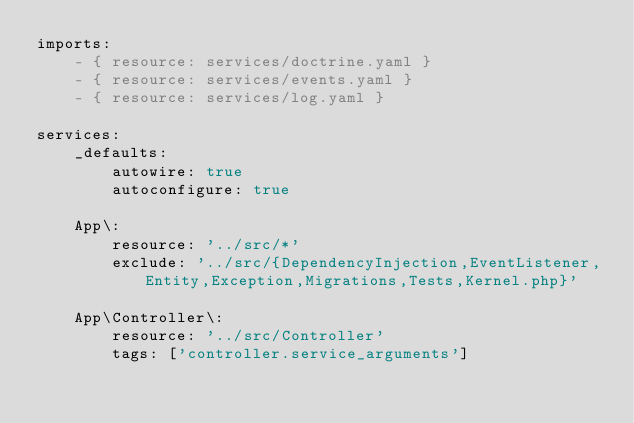Convert code to text. <code><loc_0><loc_0><loc_500><loc_500><_YAML_>imports:
    - { resource: services/doctrine.yaml }
    - { resource: services/events.yaml }
    - { resource: services/log.yaml }

services:
    _defaults:
        autowire: true
        autoconfigure: true

    App\:
        resource: '../src/*'
        exclude: '../src/{DependencyInjection,EventListener,Entity,Exception,Migrations,Tests,Kernel.php}'

    App\Controller\:
        resource: '../src/Controller'
        tags: ['controller.service_arguments']</code> 